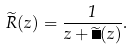<formula> <loc_0><loc_0><loc_500><loc_500>\widetilde { R } ( z ) = \frac { 1 } { z + \widetilde { \Pi } ( z ) } .</formula> 